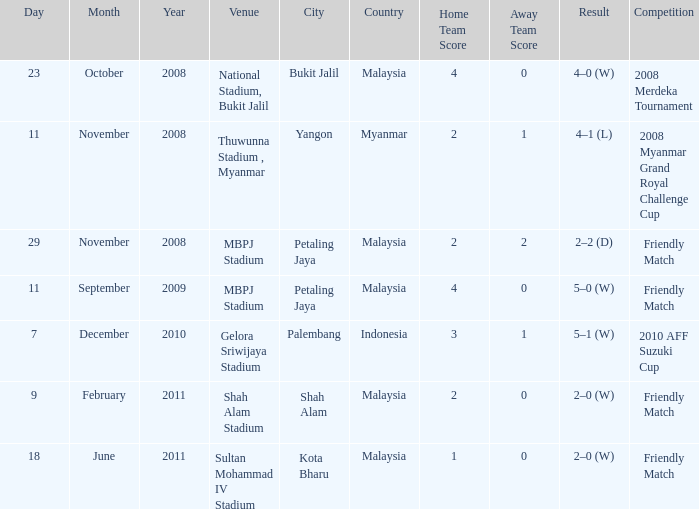What was the Score in Gelora Sriwijaya Stadium? 3–1. 